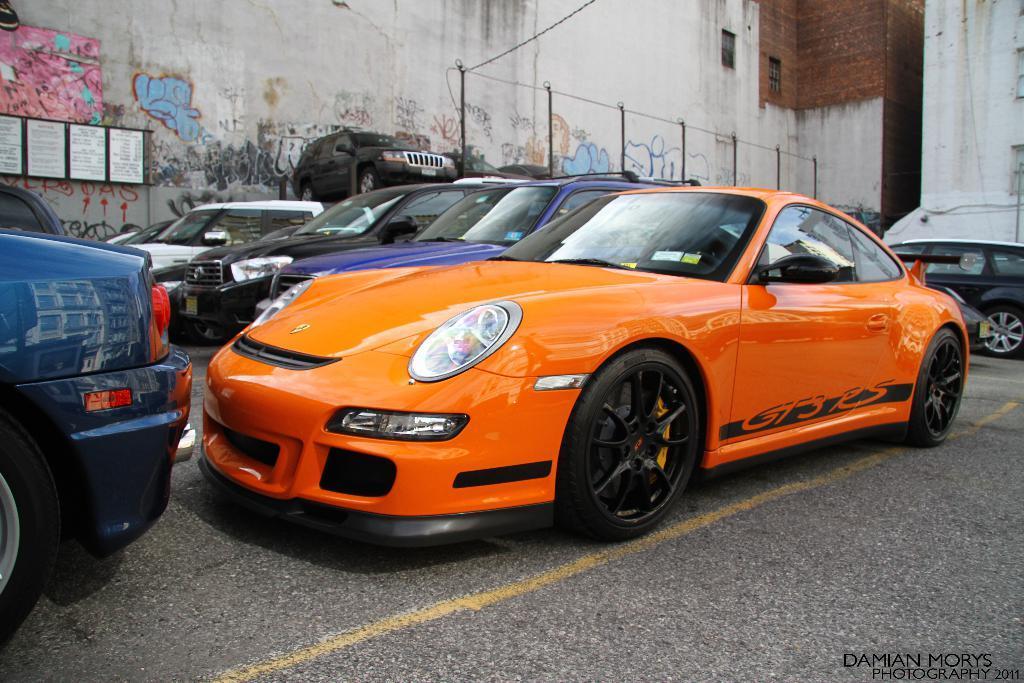In one or two sentences, can you explain what this image depicts? In this image few vehicles are on the road. Left few posters are attached to the board. Behind the vehicles there is a fence. Background there are few buildings. Left side there is some painting on the wall. 